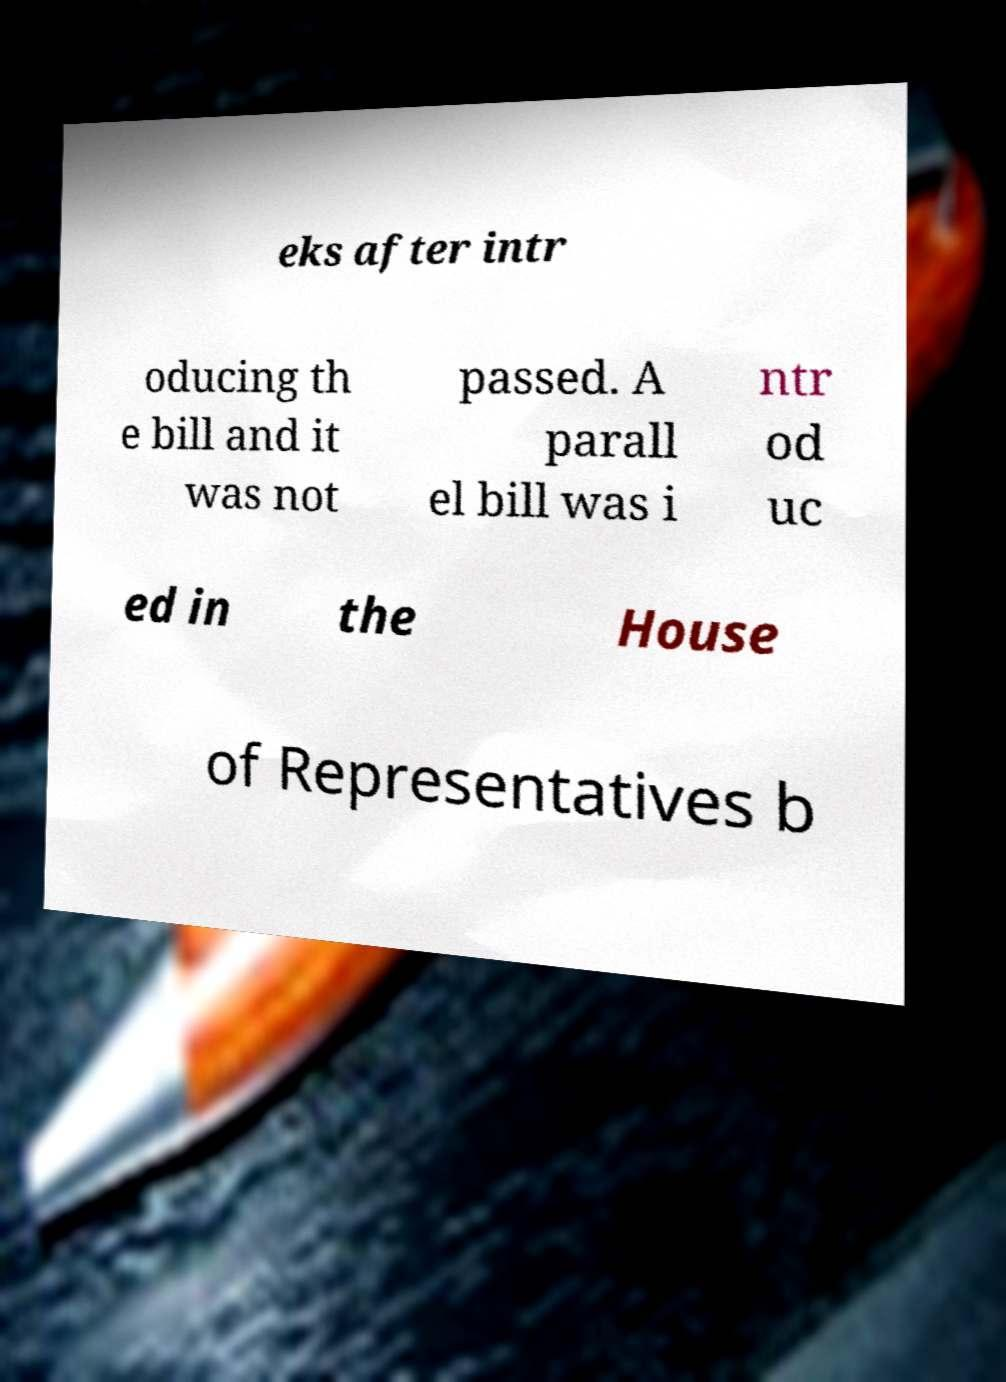Can you read and provide the text displayed in the image?This photo seems to have some interesting text. Can you extract and type it out for me? eks after intr oducing th e bill and it was not passed. A parall el bill was i ntr od uc ed in the House of Representatives b 